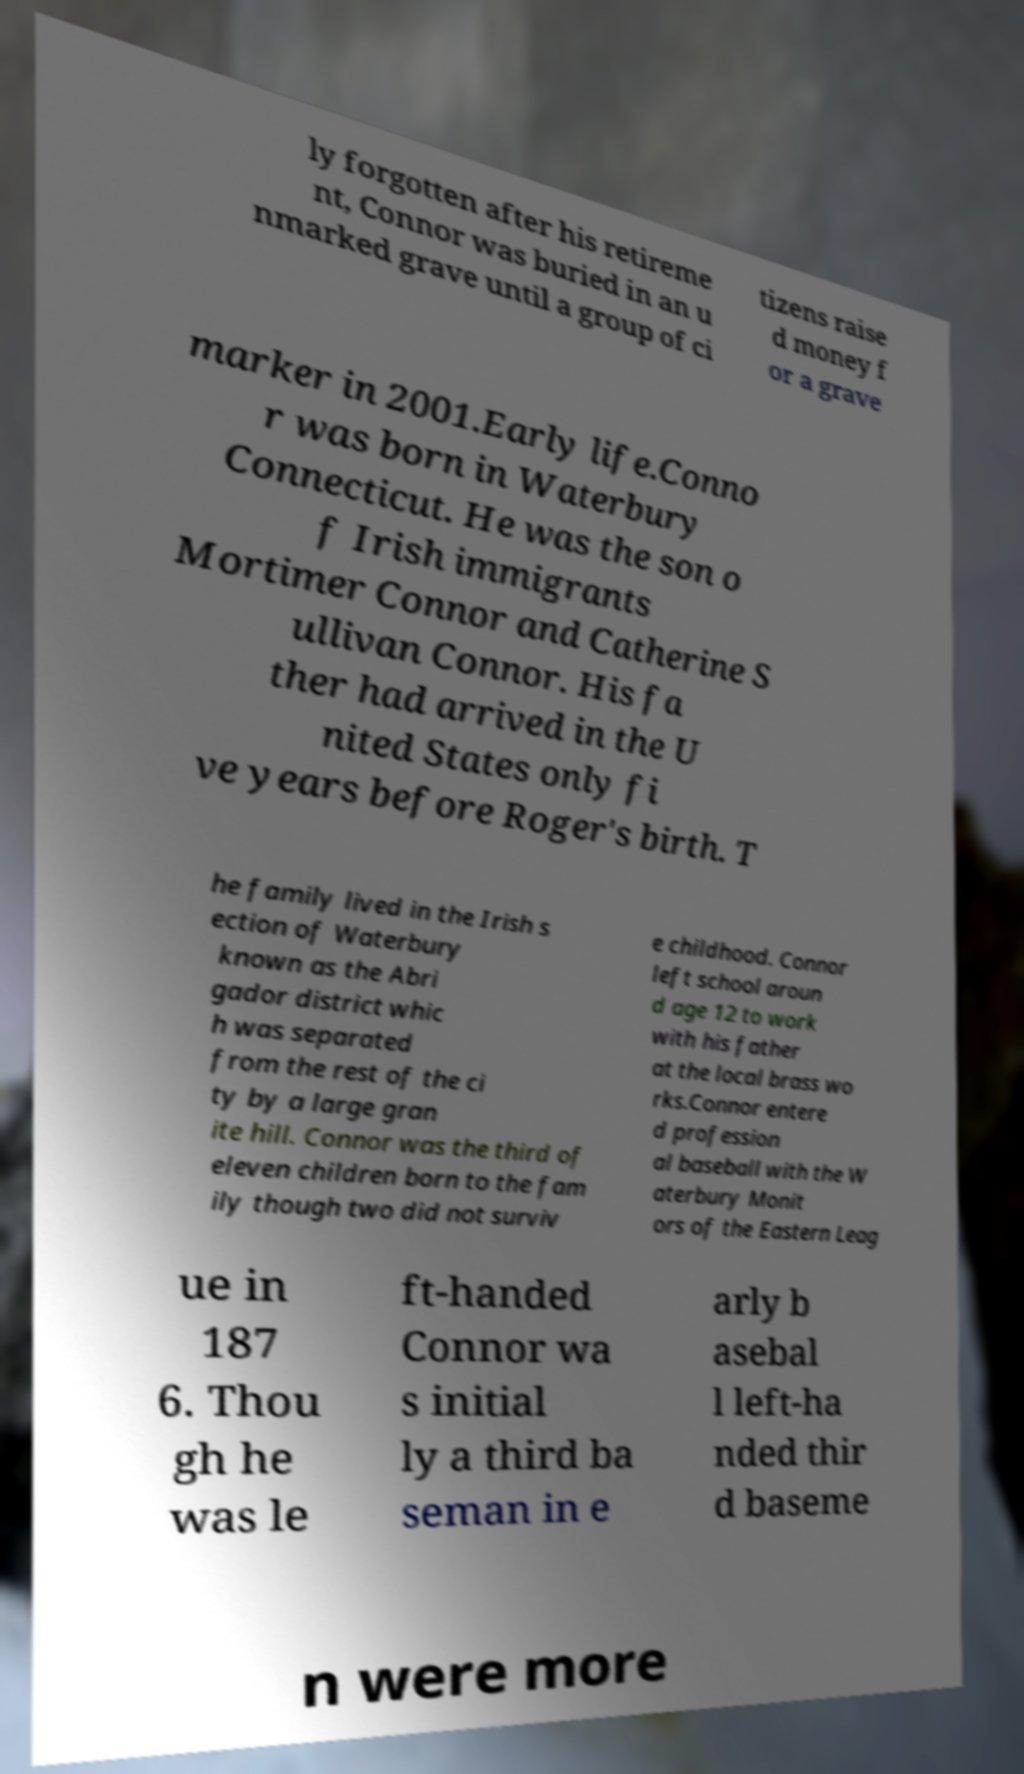Can you accurately transcribe the text from the provided image for me? ly forgotten after his retireme nt, Connor was buried in an u nmarked grave until a group of ci tizens raise d money f or a grave marker in 2001.Early life.Conno r was born in Waterbury Connecticut. He was the son o f Irish immigrants Mortimer Connor and Catherine S ullivan Connor. His fa ther had arrived in the U nited States only fi ve years before Roger's birth. T he family lived in the Irish s ection of Waterbury known as the Abri gador district whic h was separated from the rest of the ci ty by a large gran ite hill. Connor was the third of eleven children born to the fam ily though two did not surviv e childhood. Connor left school aroun d age 12 to work with his father at the local brass wo rks.Connor entere d profession al baseball with the W aterbury Monit ors of the Eastern Leag ue in 187 6. Thou gh he was le ft-handed Connor wa s initial ly a third ba seman in e arly b asebal l left-ha nded thir d baseme n were more 